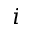<formula> <loc_0><loc_0><loc_500><loc_500>i</formula> 